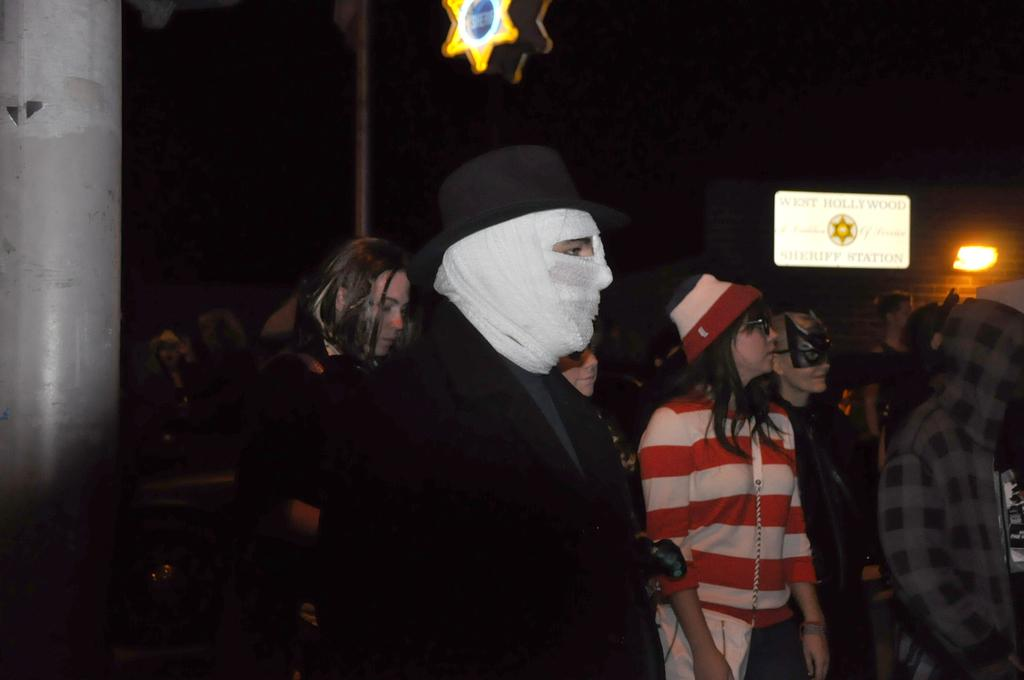How many people are present in the image? There are many people in the image. What accessories can be seen on some of the people? Some people are wearing hats, glasses (specs), and masks. What is visible in the background of the image? There is a brick wall in the background. How is the brick wall illuminated? The brick wall has light. What is located on the left side of the image? There is a pole on the left side of the image. Can you tell me how many corn plants are growing near the river in the image? There is no river or corn plants present in the image. What type of shock can be seen on the people's faces in the image? There is no indication of any shock on the people's faces in the image. 